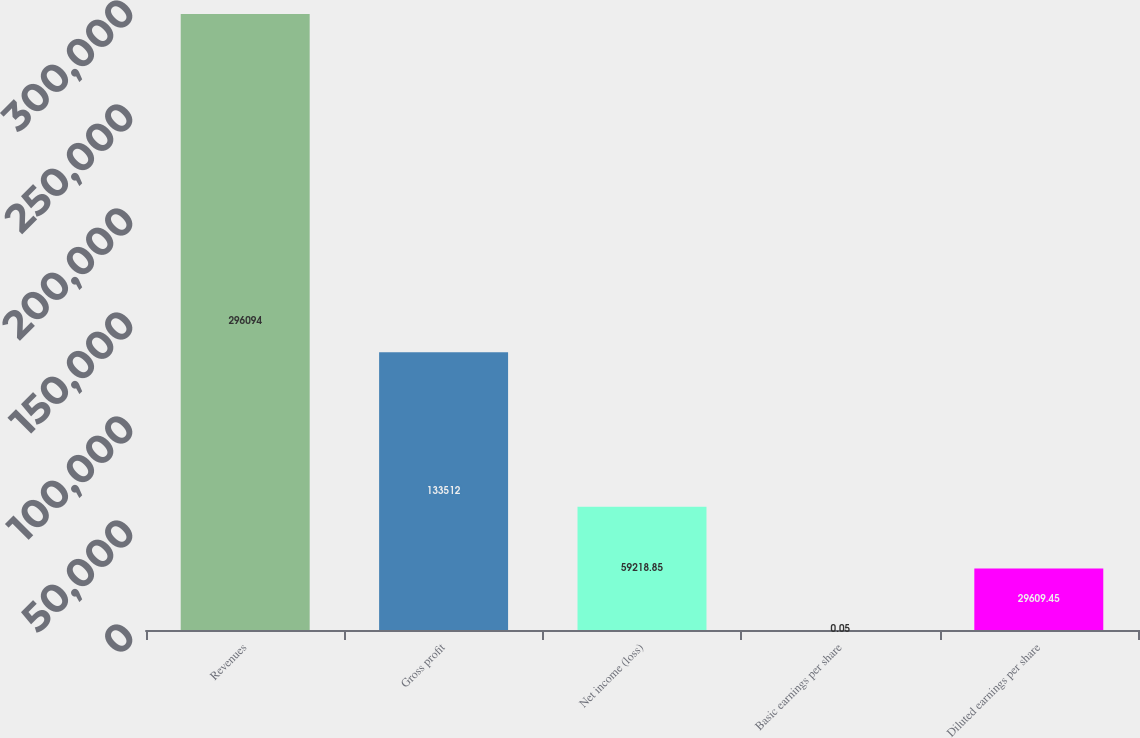Convert chart to OTSL. <chart><loc_0><loc_0><loc_500><loc_500><bar_chart><fcel>Revenues<fcel>Gross profit<fcel>Net income (loss)<fcel>Basic earnings per share<fcel>Diluted earnings per share<nl><fcel>296094<fcel>133512<fcel>59218.8<fcel>0.05<fcel>29609.5<nl></chart> 